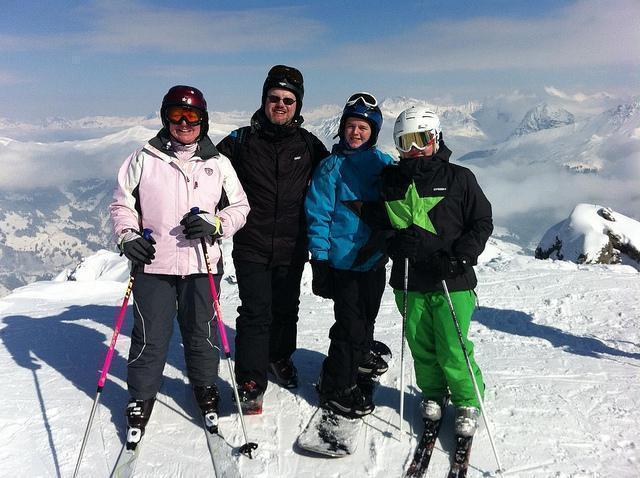What is a country that is famously a host to this sport?
From the following four choices, select the correct answer to address the question.
Options: Kenya, australia, switzerland, peru. Switzerland. 